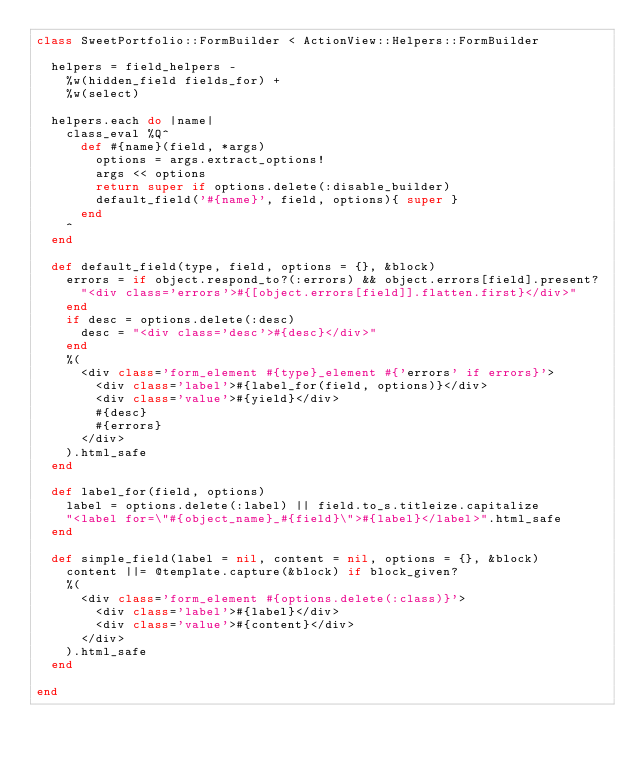Convert code to text. <code><loc_0><loc_0><loc_500><loc_500><_Ruby_>class SweetPortfolio::FormBuilder < ActionView::Helpers::FormBuilder
  
  helpers = field_helpers -
    %w(hidden_field fields_for) +
    %w(select)
    
  helpers.each do |name|
    class_eval %Q^
      def #{name}(field, *args)
        options = args.extract_options!
        args << options
        return super if options.delete(:disable_builder)
        default_field('#{name}', field, options){ super }
      end
    ^
  end
  
  def default_field(type, field, options = {}, &block)
    errors = if object.respond_to?(:errors) && object.errors[field].present?
      "<div class='errors'>#{[object.errors[field]].flatten.first}</div>"
    end
    if desc = options.delete(:desc)
      desc = "<div class='desc'>#{desc}</div>"
    end
    %(
      <div class='form_element #{type}_element #{'errors' if errors}'>
        <div class='label'>#{label_for(field, options)}</div>
        <div class='value'>#{yield}</div>
        #{desc}
        #{errors}
      </div>
    ).html_safe
  end
  
  def label_for(field, options)
    label = options.delete(:label) || field.to_s.titleize.capitalize
    "<label for=\"#{object_name}_#{field}\">#{label}</label>".html_safe
  end
  
  def simple_field(label = nil, content = nil, options = {}, &block)
    content ||= @template.capture(&block) if block_given?
    %(
      <div class='form_element #{options.delete(:class)}'>
        <div class='label'>#{label}</div>
        <div class='value'>#{content}</div>
      </div>
    ).html_safe
  end
  
end</code> 